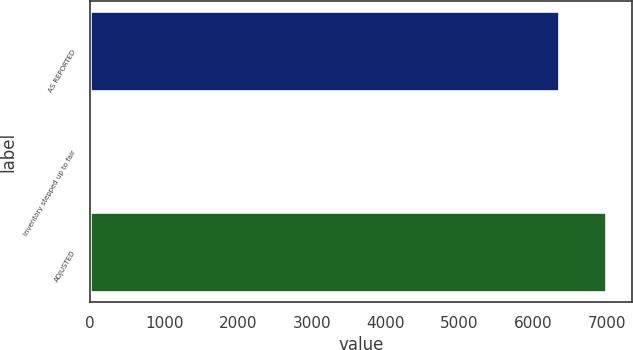Convert chart. <chart><loc_0><loc_0><loc_500><loc_500><bar_chart><fcel>AS REPORTED<fcel>Inventory stepped up to fair<fcel>ADJUSTED<nl><fcel>6356<fcel>27<fcel>6991.7<nl></chart> 